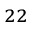<formula> <loc_0><loc_0><loc_500><loc_500>^ { 2 2 }</formula> 